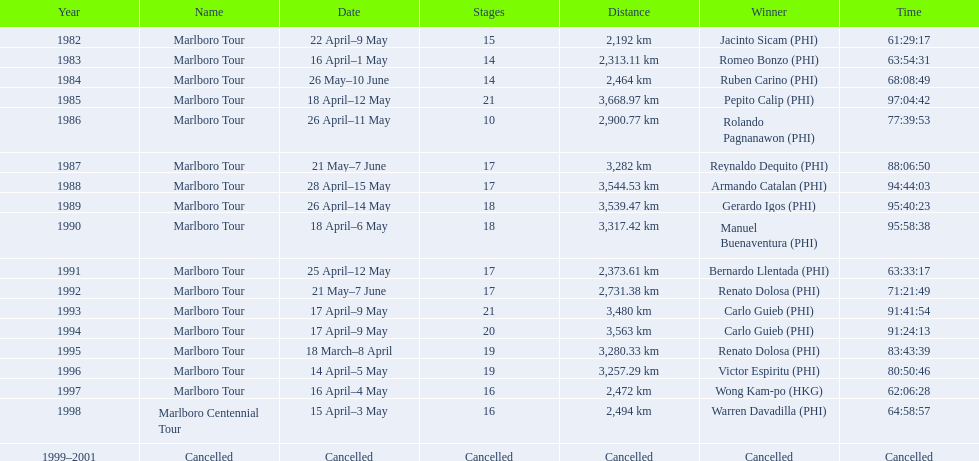When did warren davdilla (w.d.) show up in terms of year? 1998. What tour was accomplished by w.d.? Marlboro Centennial Tour. What is the time mentioned in the same row as w.d.? 64:58:57. 